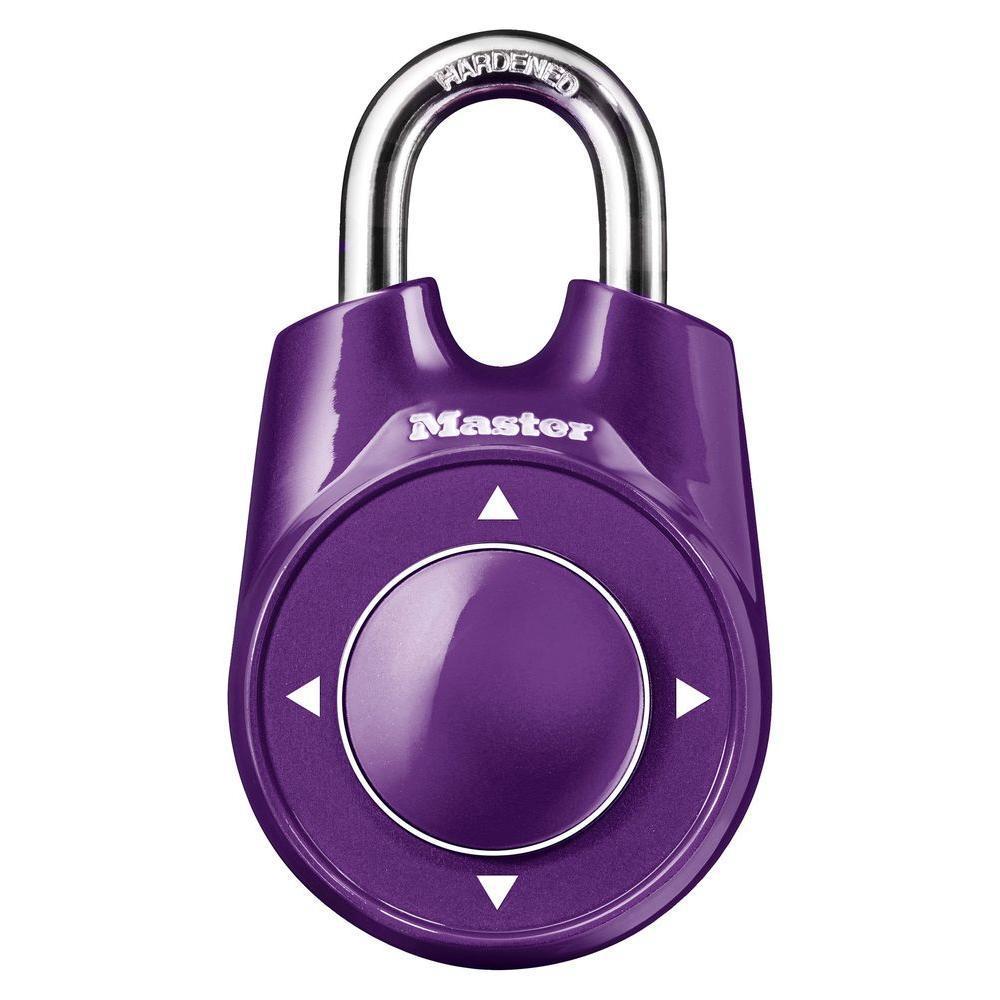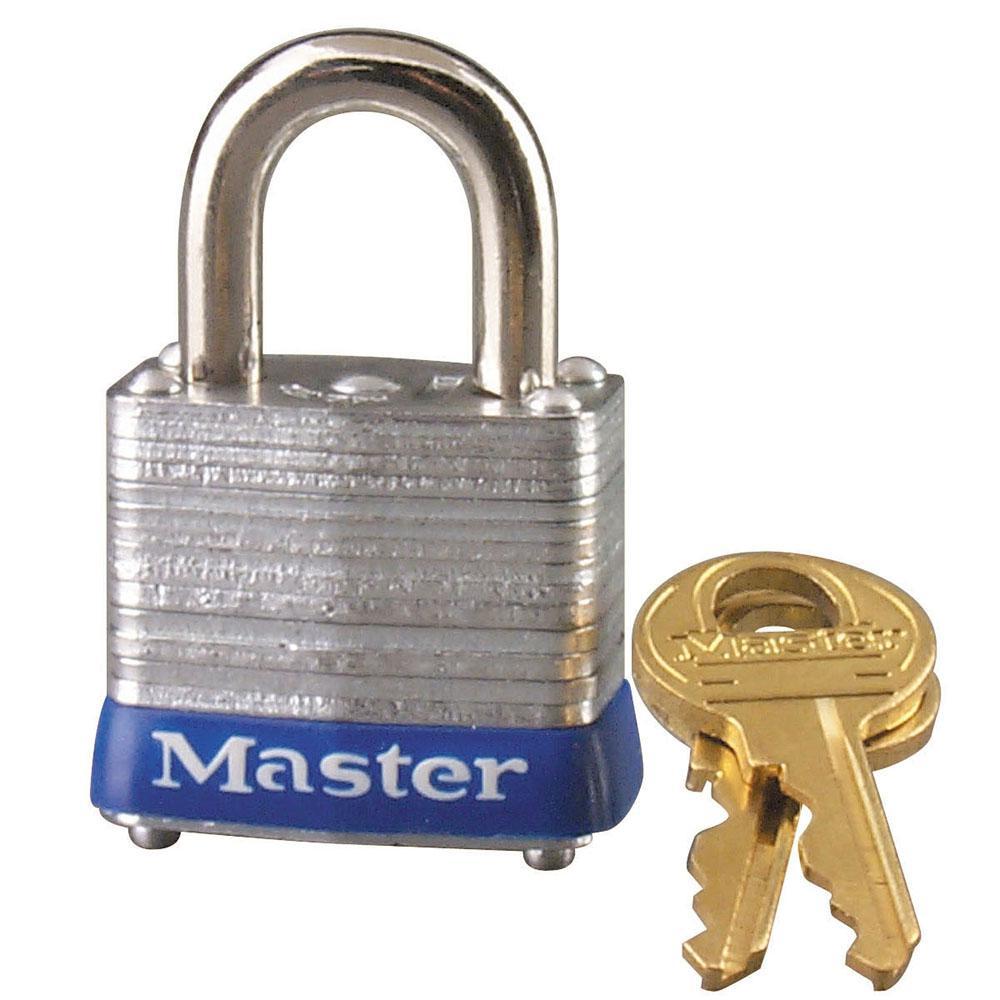The first image is the image on the left, the second image is the image on the right. For the images displayed, is the sentence "At least one of the padlocks is numbered." factually correct? Answer yes or no. No. The first image is the image on the left, the second image is the image on the right. Given the left and right images, does the statement "Two gold keys sit to the right of a silver padlock with a blue base." hold true? Answer yes or no. Yes. 